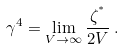<formula> <loc_0><loc_0><loc_500><loc_500>\gamma ^ { 4 } = \lim _ { V \to \infty } \frac { \zeta ^ { ^ { * } } } { 2 V } \, .</formula> 